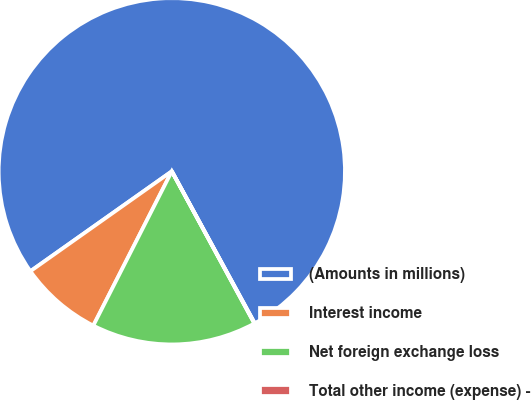Convert chart. <chart><loc_0><loc_0><loc_500><loc_500><pie_chart><fcel>(Amounts in millions)<fcel>Interest income<fcel>Net foreign exchange loss<fcel>Total other income (expense) -<nl><fcel>76.84%<fcel>7.72%<fcel>15.4%<fcel>0.04%<nl></chart> 